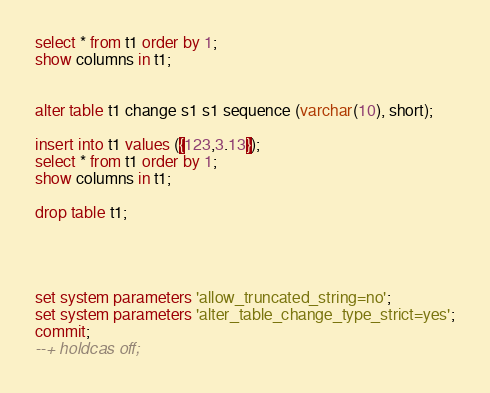<code> <loc_0><loc_0><loc_500><loc_500><_SQL_>
select * from t1 order by 1;
show columns in t1;


alter table t1 change s1 s1 sequence (varchar(10), short);

insert into t1 values ({123,3.13});
select * from t1 order by 1;
show columns in t1;

drop table t1;




set system parameters 'allow_truncated_string=no';
set system parameters 'alter_table_change_type_strict=yes';
commit;
--+ holdcas off;
</code> 